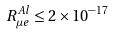Convert formula to latex. <formula><loc_0><loc_0><loc_500><loc_500>R _ { \mu e } ^ { A l } \leq 2 \times 1 0 ^ { - 1 7 } \quad</formula> 